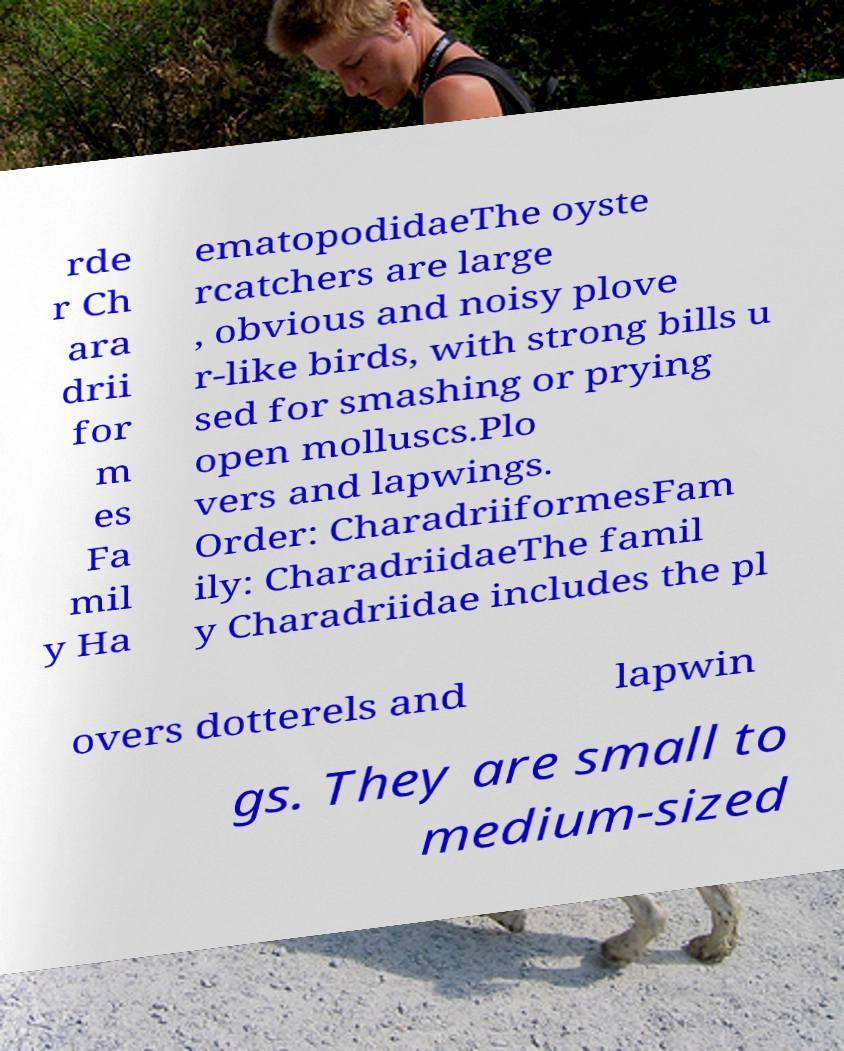There's text embedded in this image that I need extracted. Can you transcribe it verbatim? rde r Ch ara drii for m es Fa mil y Ha ematopodidaeThe oyste rcatchers are large , obvious and noisy plove r-like birds, with strong bills u sed for smashing or prying open molluscs.Plo vers and lapwings. Order: CharadriiformesFam ily: CharadriidaeThe famil y Charadriidae includes the pl overs dotterels and lapwin gs. They are small to medium-sized 